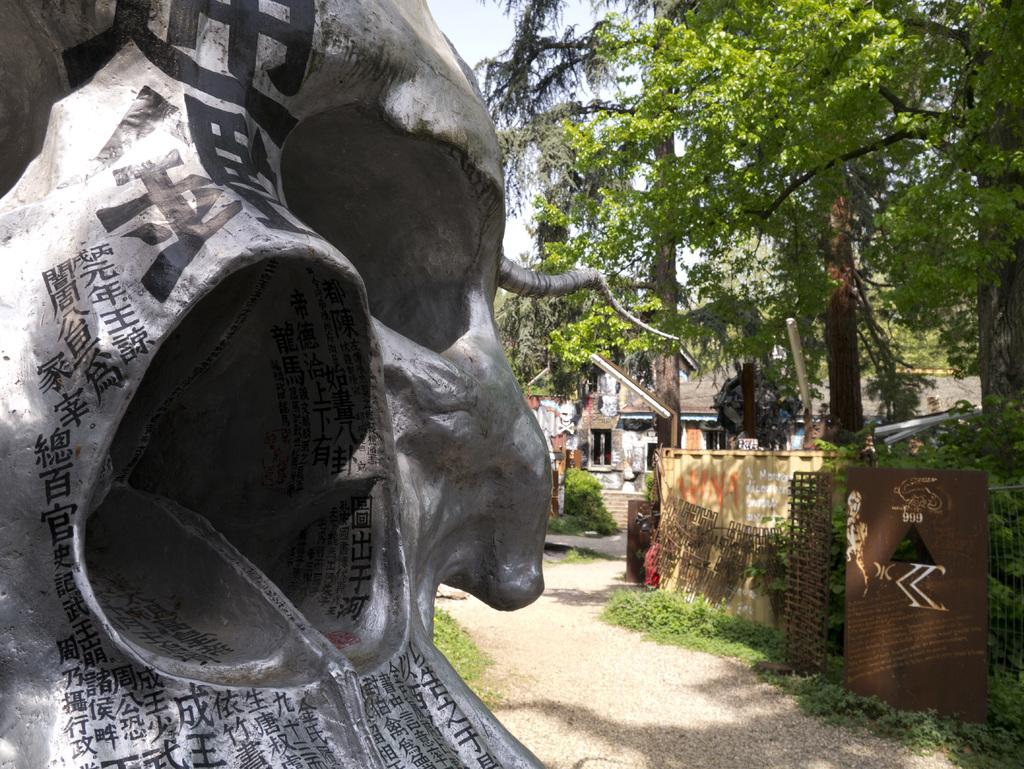What is located on the left side of the image? There is a statue on the left side of the image. What can be seen on the right side of the image? There are houses and trees on the right side of the image. What does the statue taste like in the image? The statue is not an edible object, so it does not have a taste. How does the statue breathe in the image? The statue is an inanimate object, so it does not breathe. 